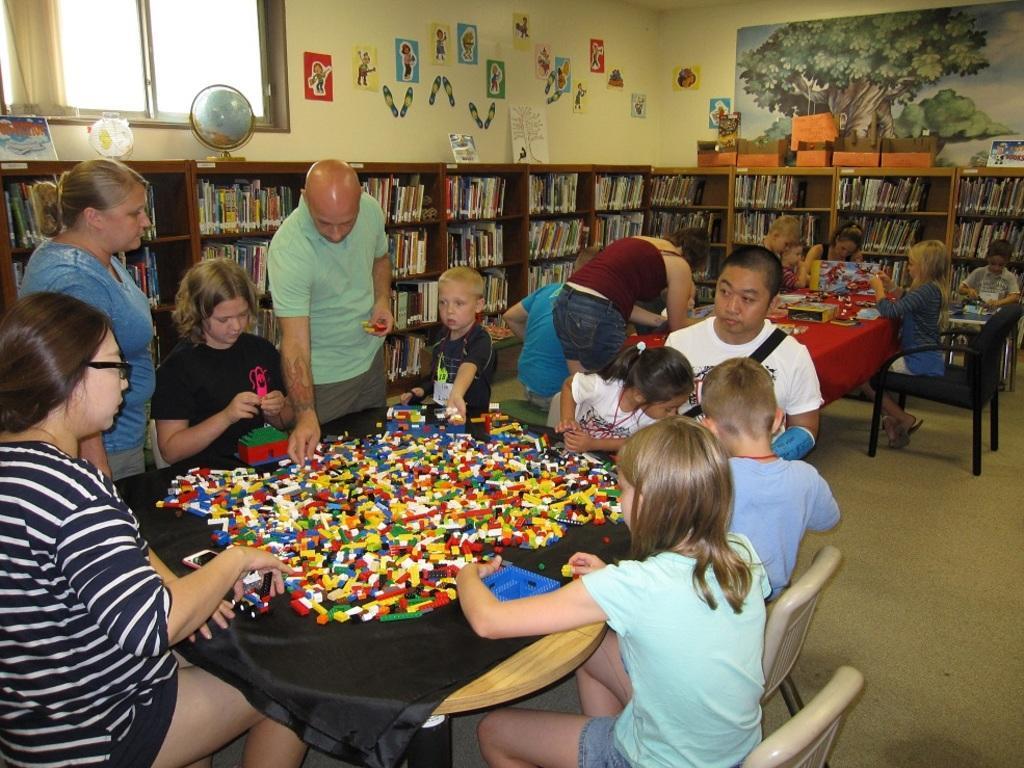Can you describe this image briefly? There is a group of a people. They are sitting on a chair. The three persons are standing. There is a table. There is a logos,mobile on a table. We can see the background is window,poster,cupboard on a books ,globe. 